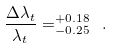Convert formula to latex. <formula><loc_0><loc_0><loc_500><loc_500>\frac { \Delta \lambda _ { t } } { \lambda _ { t } } = _ { - 0 . 2 5 } ^ { + 0 . 1 8 } \ .</formula> 